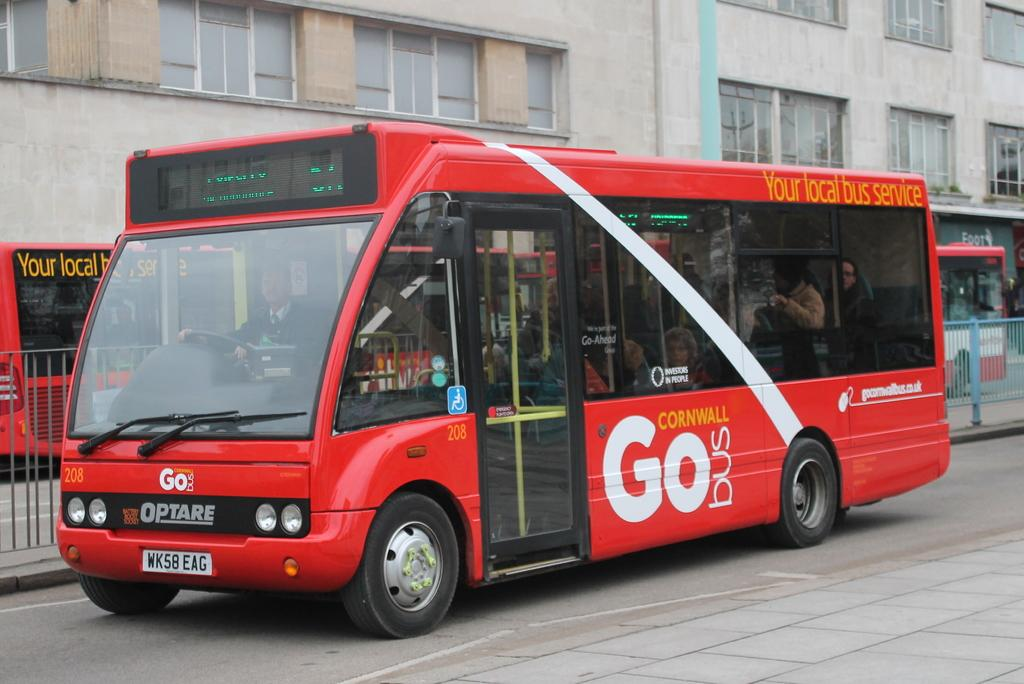What is the main subject of the image? The main subject of the image is buses, which are located in the center of the image. What is at the bottom of the image? There is a road at the bottom of the image. What can be seen in the image that separates different areas? There is a fence in the image. What is visible in the background of the image? There is a building in the background of the image. How many seats are available on the fence in the image? There are no seats on the fence in the image, as it is a barrier and not a piece of furniture. 